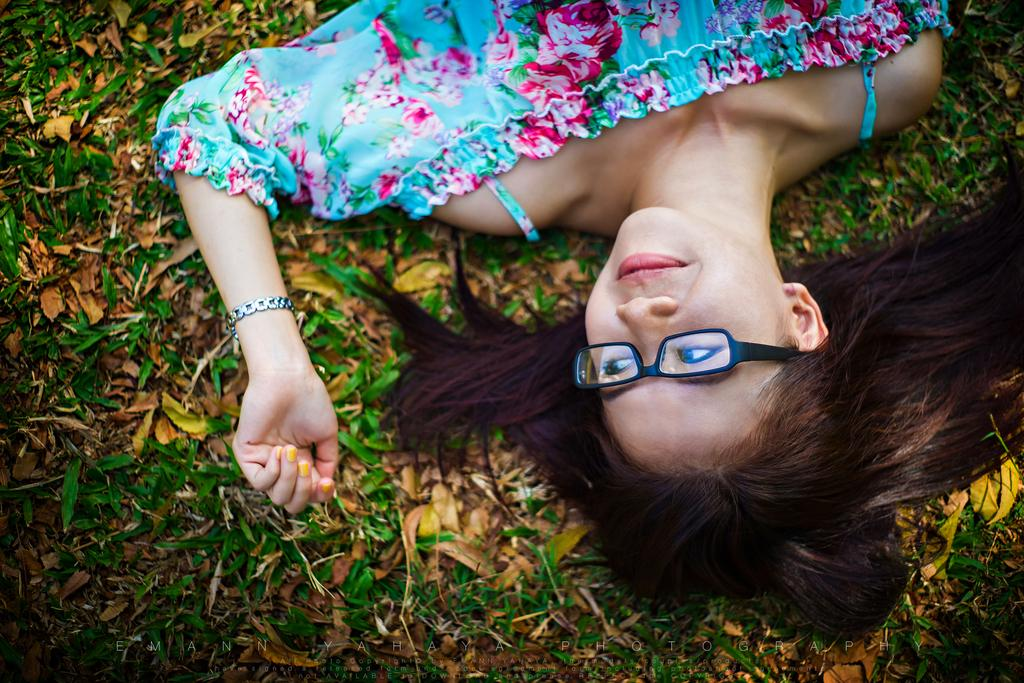What is the main subject of the image? There is a person in the image. What is the person doing in the image? The person is lying on leaves. How is the person's mood depicted in the image? The person is smiling. Can you describe any additional features of the image? There is a watermark on the image. What type of plantation can be seen in the image? There is no plantation present in the image; it features a person lying on leaves. What part of the person's body is being pumped in the image? There is no pumping of any body part depicted in the image; the person is simply lying on leaves and smiling. 